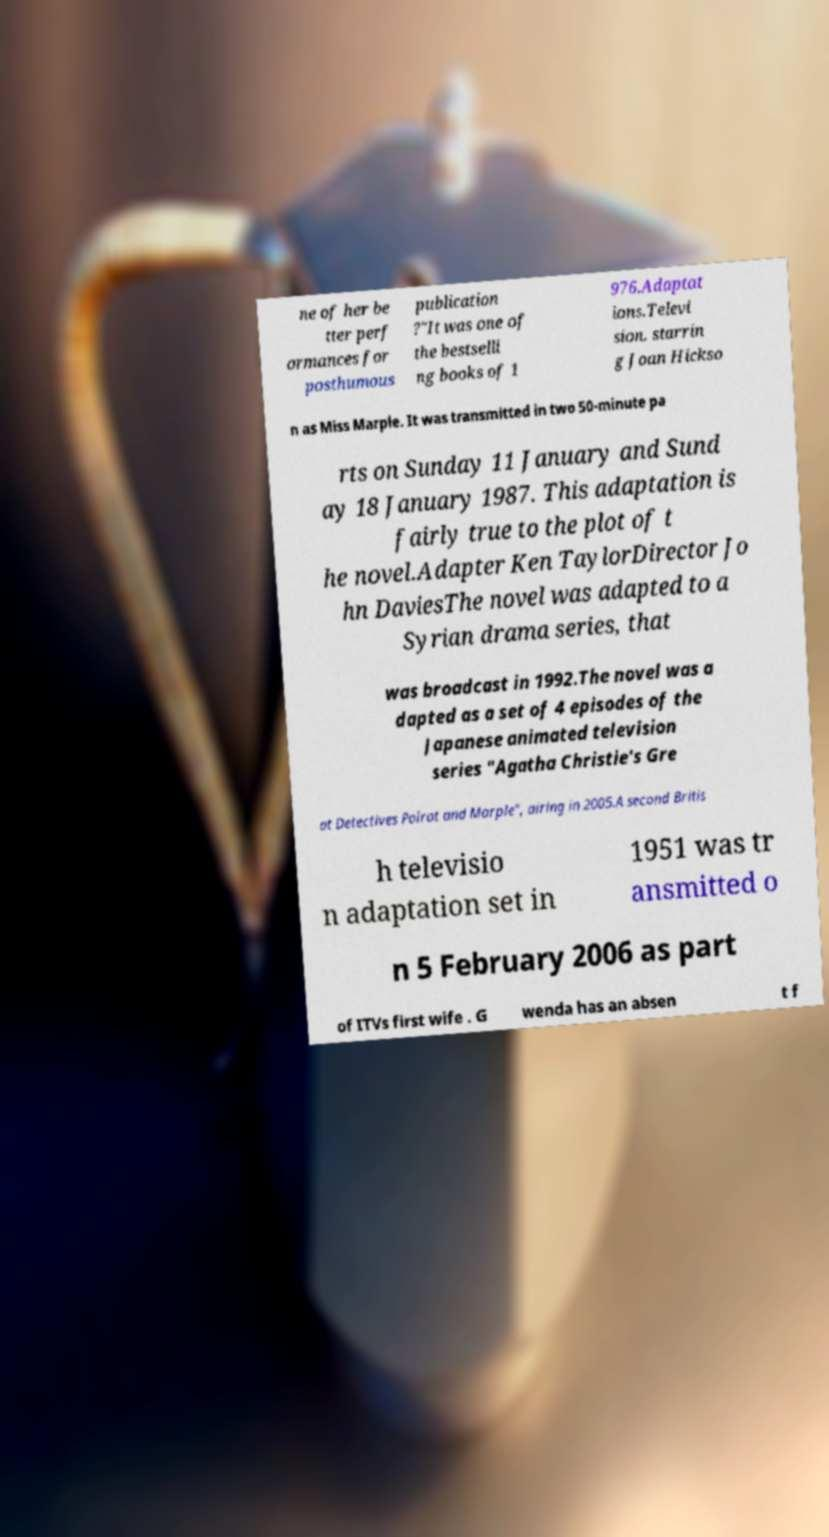There's text embedded in this image that I need extracted. Can you transcribe it verbatim? ne of her be tter perf ormances for posthumous publication ?"It was one of the bestselli ng books of 1 976.Adaptat ions.Televi sion. starrin g Joan Hickso n as Miss Marple. It was transmitted in two 50-minute pa rts on Sunday 11 January and Sund ay 18 January 1987. This adaptation is fairly true to the plot of t he novel.Adapter Ken TaylorDirector Jo hn DaviesThe novel was adapted to a Syrian drama series, that was broadcast in 1992.The novel was a dapted as a set of 4 episodes of the Japanese animated television series "Agatha Christie's Gre at Detectives Poirot and Marple", airing in 2005.A second Britis h televisio n adaptation set in 1951 was tr ansmitted o n 5 February 2006 as part of ITVs first wife . G wenda has an absen t f 